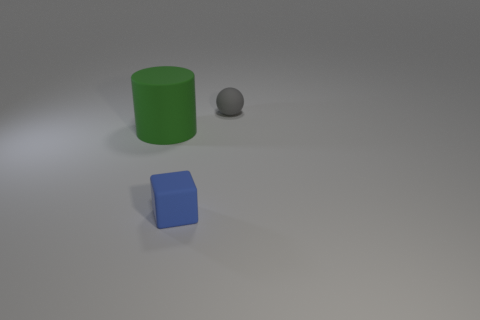There is a gray thing that is the same size as the blue rubber block; what material is it?
Your response must be concise. Rubber. Are there any small things made of the same material as the large green thing?
Provide a short and direct response. Yes. The rubber object on the left side of the tiny rubber thing in front of the small rubber thing that is behind the large green object is what color?
Offer a terse response. Green. Are there fewer gray rubber objects to the left of the big rubber cylinder than gray balls?
Provide a succinct answer. Yes. What number of blue shiny blocks are there?
Make the answer very short. 0. Does the big thing have the same shape as the object in front of the big rubber thing?
Your answer should be compact. No. Is the number of blue blocks to the right of the blue block less than the number of tiny rubber things that are in front of the green cylinder?
Offer a terse response. Yes. Are there any other things that are the same shape as the big green rubber object?
Give a very brief answer. No. Is there anything else that has the same material as the large green cylinder?
Ensure brevity in your answer.  Yes. What is the size of the sphere?
Keep it short and to the point. Small. 